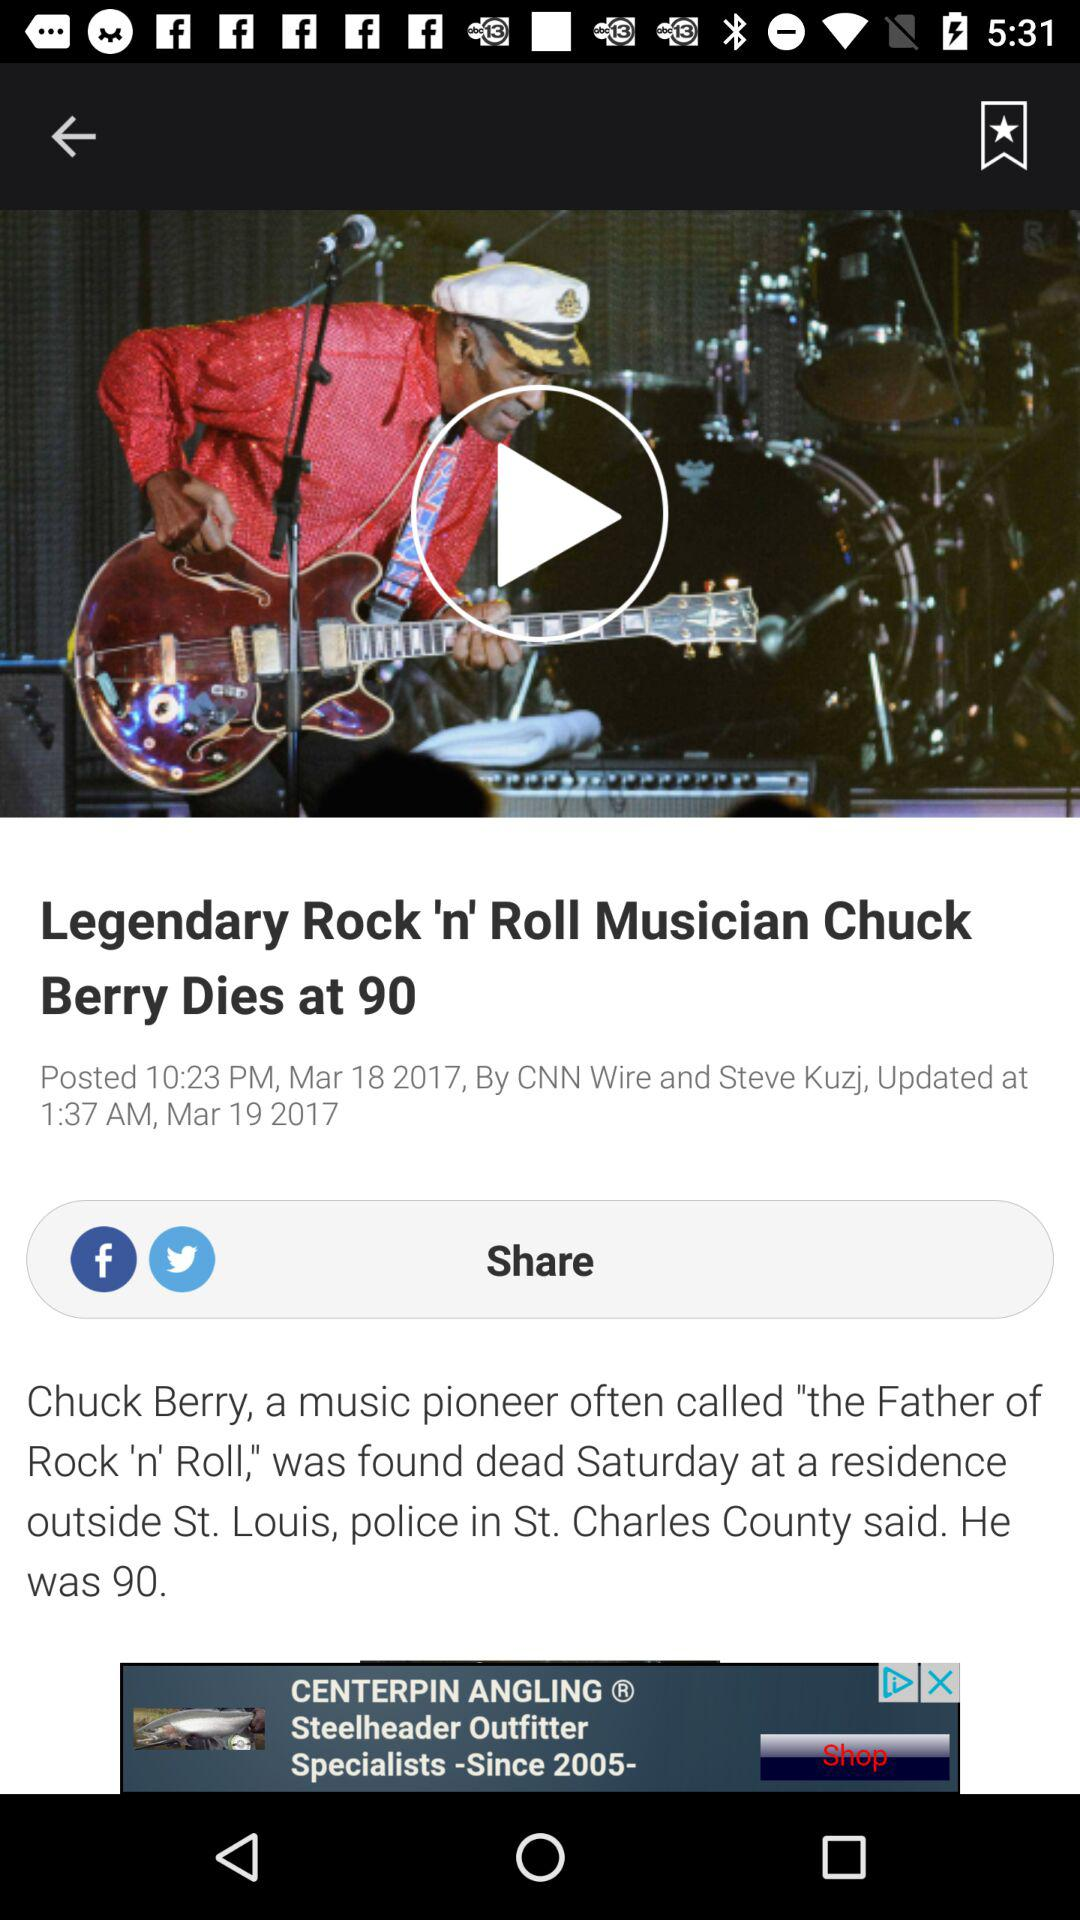Which are the different sharing options? The different sharing options are "Facebook" and "Twitter". 